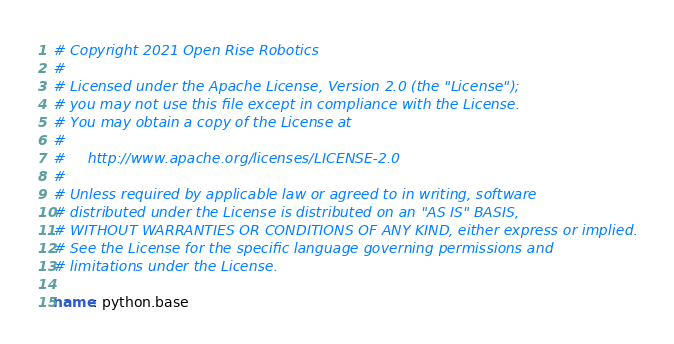<code> <loc_0><loc_0><loc_500><loc_500><_YAML_># Copyright 2021 Open Rise Robotics
#
# Licensed under the Apache License, Version 2.0 (the "License");
# you may not use this file except in compliance with the License.
# You may obtain a copy of the License at
#
#     http://www.apache.org/licenses/LICENSE-2.0
#
# Unless required by applicable law or agreed to in writing, software
# distributed under the License is distributed on an "AS IS" BASIS,
# WITHOUT WARRANTIES OR CONDITIONS OF ANY KIND, either express or implied.
# See the License for the specific language governing permissions and
# limitations under the License.

name: python.base
</code> 